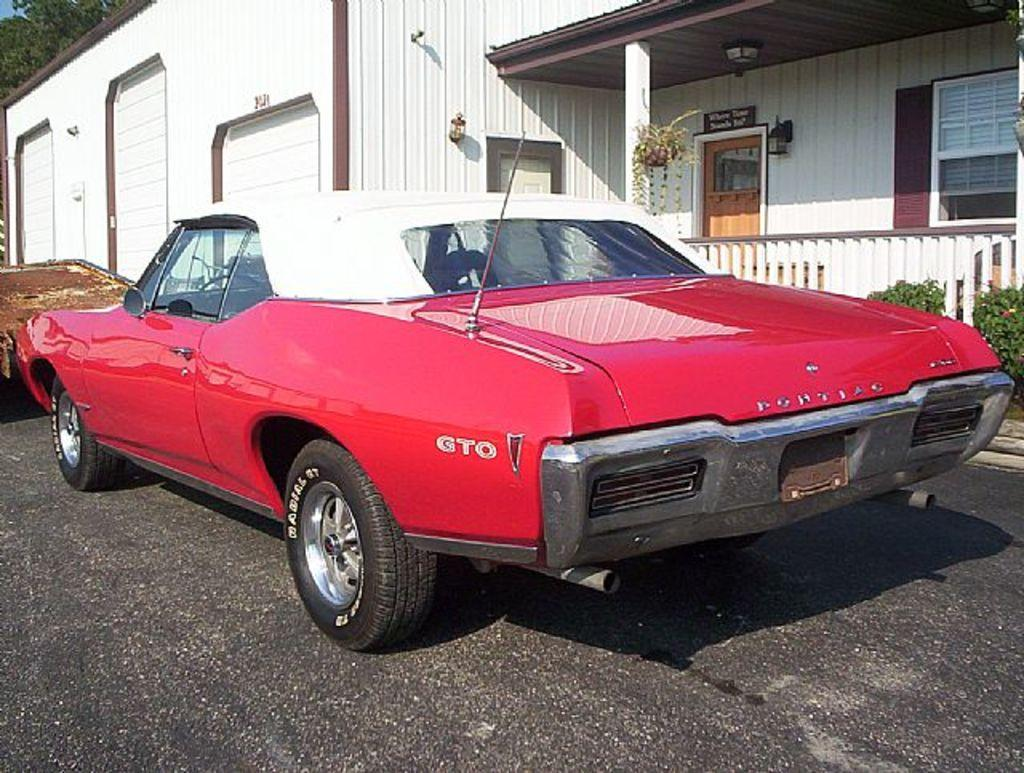What is on the road in the image? There is a vehicle on the road in the image. What type of vegetation can be seen in the image? Plants and trees are visible in the image. What type of structure is present in the image? There is a house in the image. What part of the natural environment is visible in the image? The sky is visible in the image. What type of lunch is the farmer eating in the image? There is no farmer or lunch present in the image. 